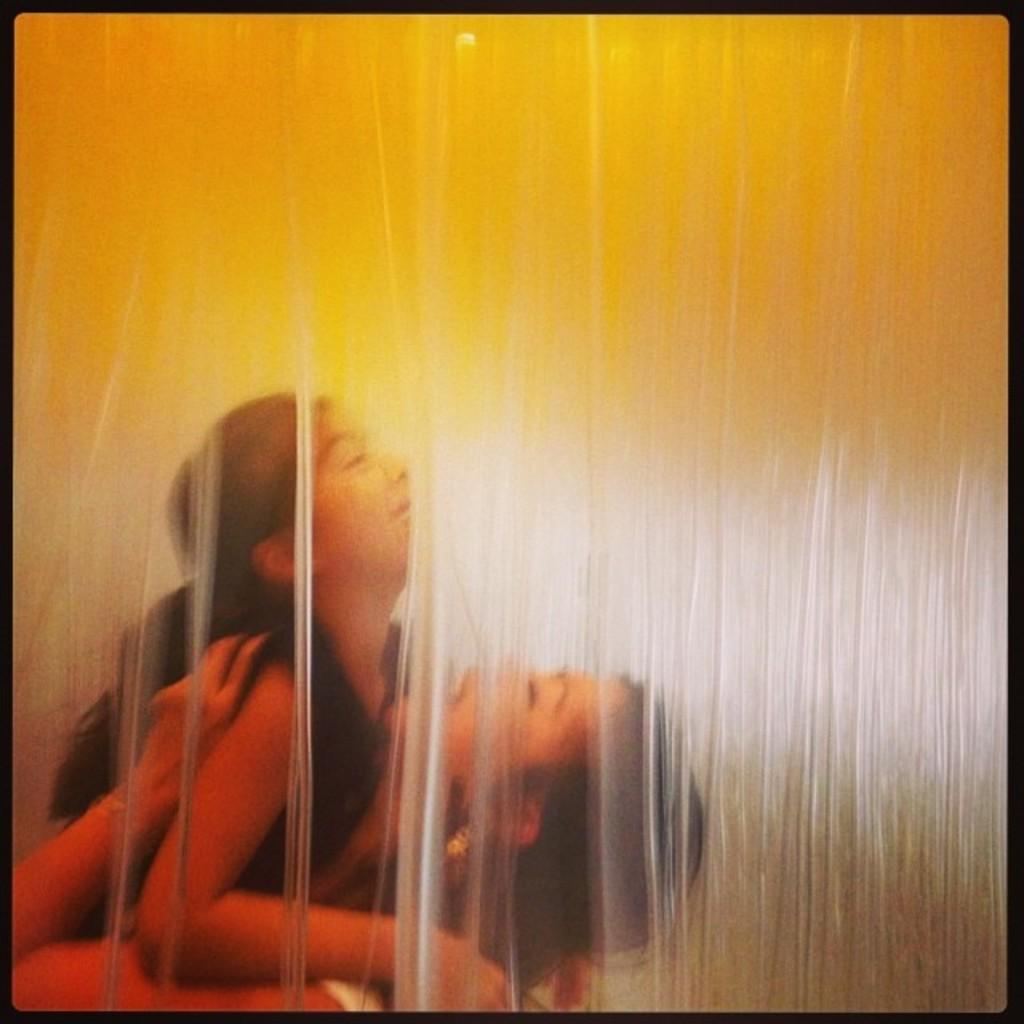Can you describe this image briefly? In this picture there is a woman who is wearing white dress. She is holding a girl and she is wearing a black dress. Both of them are laughing. beside them there is a plastic cover. 